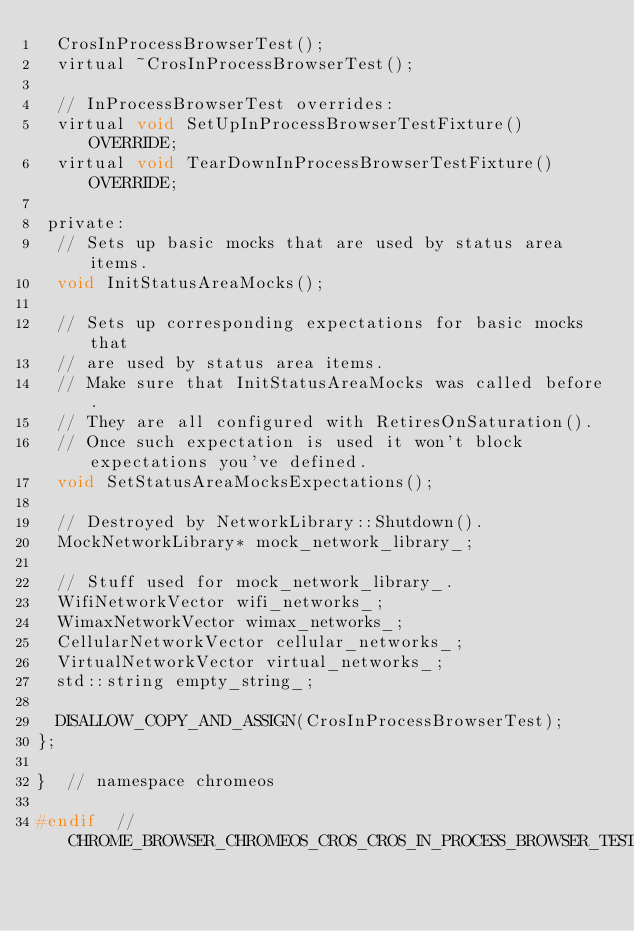Convert code to text. <code><loc_0><loc_0><loc_500><loc_500><_C_>  CrosInProcessBrowserTest();
  virtual ~CrosInProcessBrowserTest();

  // InProcessBrowserTest overrides:
  virtual void SetUpInProcessBrowserTestFixture() OVERRIDE;
  virtual void TearDownInProcessBrowserTestFixture() OVERRIDE;

 private:
  // Sets up basic mocks that are used by status area items.
  void InitStatusAreaMocks();

  // Sets up corresponding expectations for basic mocks that
  // are used by status area items.
  // Make sure that InitStatusAreaMocks was called before.
  // They are all configured with RetiresOnSaturation().
  // Once such expectation is used it won't block expectations you've defined.
  void SetStatusAreaMocksExpectations();

  // Destroyed by NetworkLibrary::Shutdown().
  MockNetworkLibrary* mock_network_library_;

  // Stuff used for mock_network_library_.
  WifiNetworkVector wifi_networks_;
  WimaxNetworkVector wimax_networks_;
  CellularNetworkVector cellular_networks_;
  VirtualNetworkVector virtual_networks_;
  std::string empty_string_;

  DISALLOW_COPY_AND_ASSIGN(CrosInProcessBrowserTest);
};

}  // namespace chromeos

#endif  // CHROME_BROWSER_CHROMEOS_CROS_CROS_IN_PROCESS_BROWSER_TEST_H_
</code> 